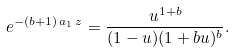<formula> <loc_0><loc_0><loc_500><loc_500>e ^ { - ( b + 1 ) \, a _ { 1 } \, z } = \frac { u ^ { 1 + b } } { ( 1 - u ) ( 1 + b u ) ^ { b } } .</formula> 